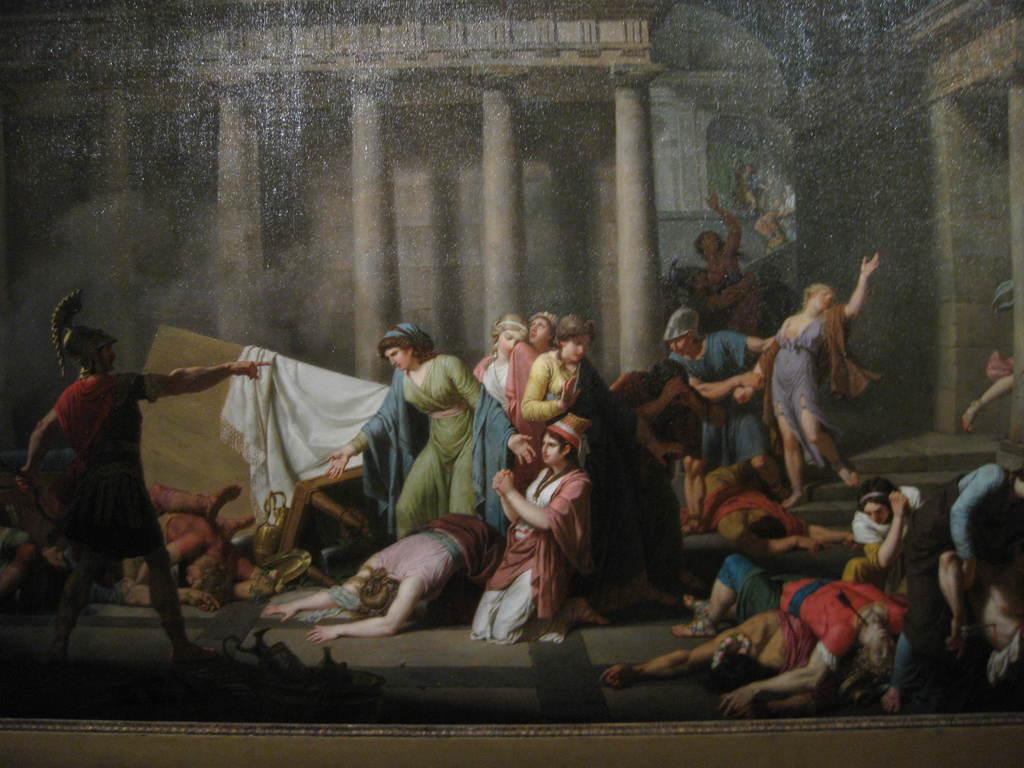What are the people in the image doing? Some people are standing, and some are lying on the floor. Can you describe the positions of the people in the image? Yes, some people are standing, while others are lying down. What can be seen in the background of the image? There are pillars visible in the background of the image. What type of eggnog is being served at the birthday party in the image? There is no mention of eggnog or a birthday party in the image; it only depicts people standing and lying on the floor with pillars in the background. 